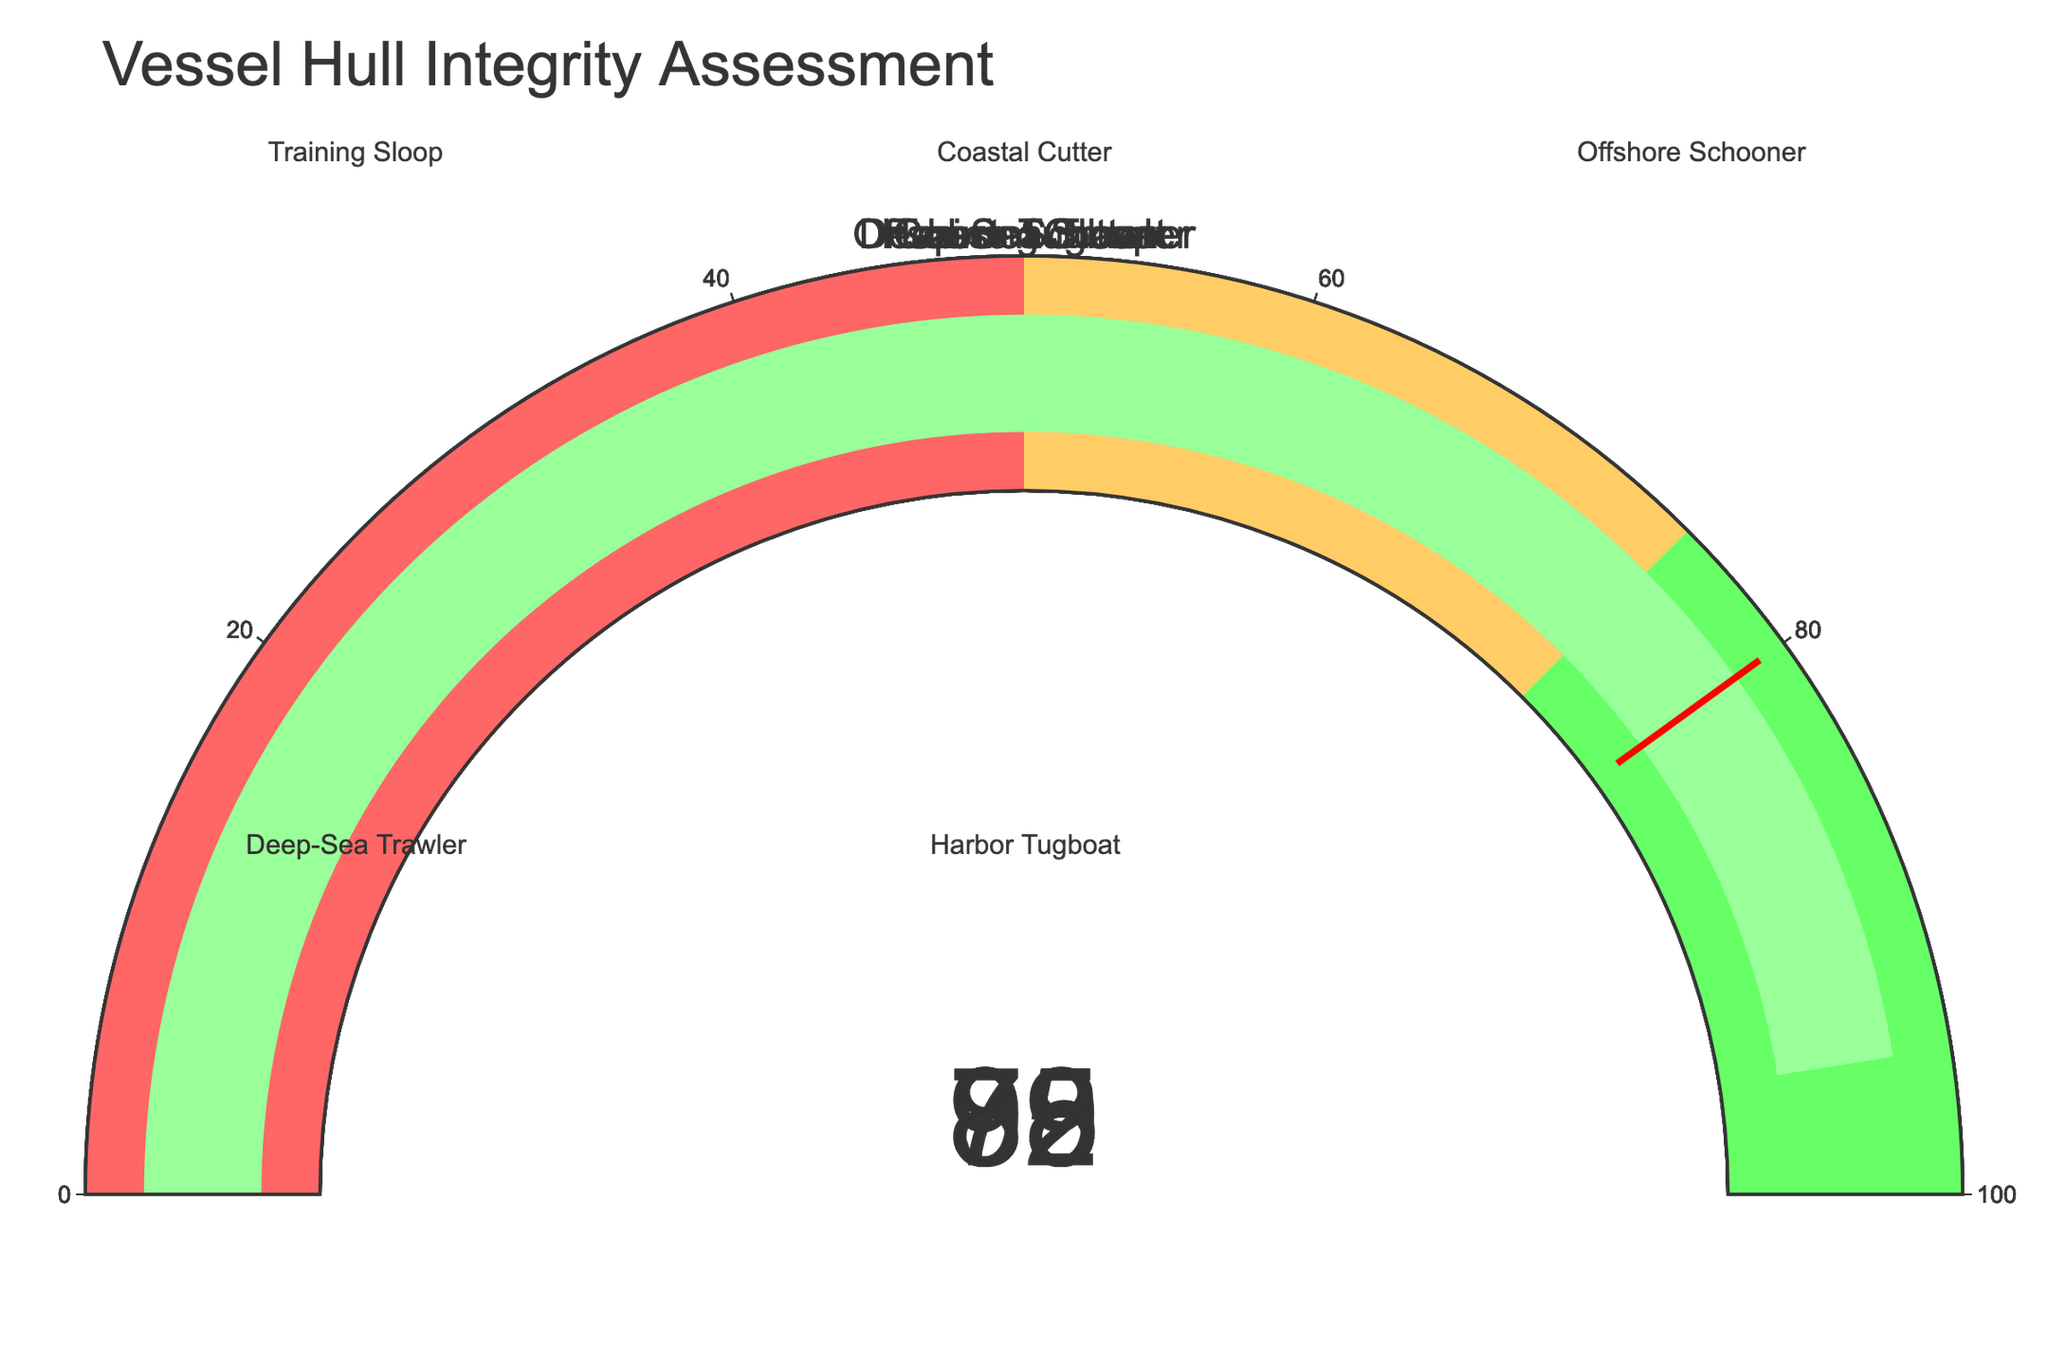What is the Hull Integrity Percentage of the Coastal Cutter? The figure for the Coastal Cutter shows a gauge displaying a value of 88 in the center. This value represents the Hull Integrity Percentage.
Answer: 88 Which vessel has the highest Hull Integrity Percentage? Among the displayed gauges, the Harbor Tugboat has the highest value showing at 95 on its gauge.
Answer: Harbor Tugboat What is the lowest Hull Integrity Percentage displayed on the chart? The lowest value on the gauges is for the Offshore Schooner, which shows a Hull Integrity Percentage of 79.
Answer: 79 What is the difference between the Hull Integrity Percentage of the Deep-Sea Trawler and the Offshore Schooner? The Deep-Sea Trawler displays a Hull Integrity Percentage of 85, while the Offshore Schooner shows 79. The difference is calculated as 85 - 79 = 6.
Answer: 6 What color bar indicates the Hull Integrity Percentage for the Training Sloop? The Training Sloop's gauge is colored in a shade of green.
Answer: Green How many vessels have a Hull Integrity Percentage greater than 80? The gauges for the Training Sloop, Coastal Cutter, Deep-Sea Trawler, and Harbor Tugboat have values greater than 80 (92, 88, 85, and 95, respectively), totaling 4 vessels.
Answer: 4 What is the average Hull Integrity Percentage of all the vessels? The Hull Integrity Percentages are 92, 88, 79, 85, and 95. Summing these yields 92 + 88 + 79 + 85 + 95 = 439. Dividing by 5, the average is 439 / 5 = 87.8
Answer: 87.8 Which vessels fall within the 75-100 integrity range as depicted on the gauges? According to the color-coded ranges on the gauges, the Training Sloop, Coastal Cutter, Deep-Sea Trawler, Harbor Tugboat, and Offshore Schooner all have values between 75 and 100.
Answer: Training Sloop, Coastal Cutter, Offshore Schooner, Deep-Sea Trawler, Harbor Tugboat 